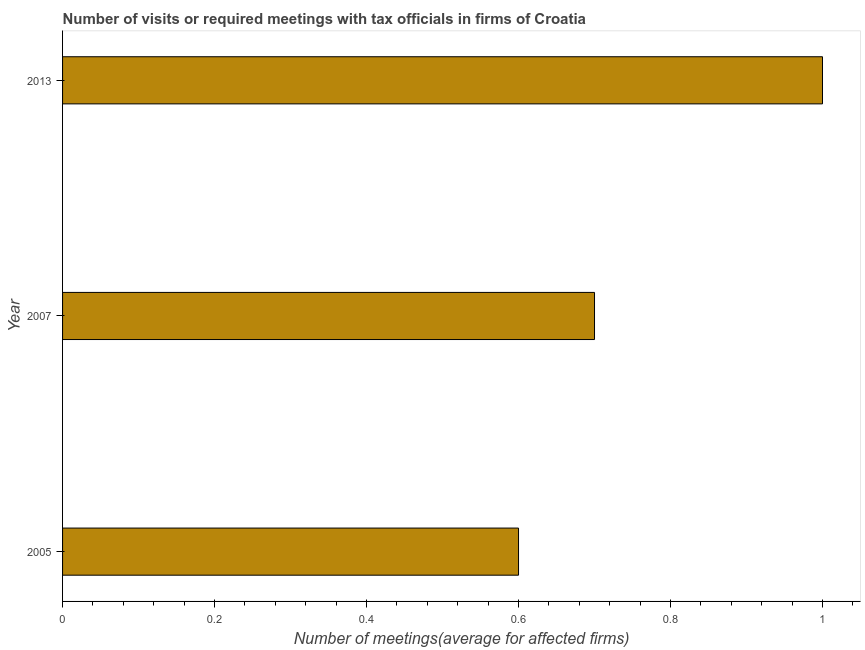What is the title of the graph?
Your answer should be compact. Number of visits or required meetings with tax officials in firms of Croatia. What is the label or title of the X-axis?
Your response must be concise. Number of meetings(average for affected firms). What is the number of required meetings with tax officials in 2005?
Your answer should be very brief. 0.6. What is the sum of the number of required meetings with tax officials?
Your response must be concise. 2.3. What is the difference between the number of required meetings with tax officials in 2007 and 2013?
Ensure brevity in your answer.  -0.3. What is the average number of required meetings with tax officials per year?
Offer a terse response. 0.77. What is the median number of required meetings with tax officials?
Your answer should be very brief. 0.7. In how many years, is the number of required meetings with tax officials greater than 0.24 ?
Give a very brief answer. 3. What is the ratio of the number of required meetings with tax officials in 2005 to that in 2007?
Provide a short and direct response. 0.86. What is the difference between the highest and the second highest number of required meetings with tax officials?
Keep it short and to the point. 0.3. What is the difference between the highest and the lowest number of required meetings with tax officials?
Ensure brevity in your answer.  0.4. In how many years, is the number of required meetings with tax officials greater than the average number of required meetings with tax officials taken over all years?
Keep it short and to the point. 1. How many bars are there?
Keep it short and to the point. 3. How many years are there in the graph?
Offer a terse response. 3. Are the values on the major ticks of X-axis written in scientific E-notation?
Offer a very short reply. No. What is the Number of meetings(average for affected firms) of 2005?
Offer a very short reply. 0.6. What is the difference between the Number of meetings(average for affected firms) in 2005 and 2013?
Your response must be concise. -0.4. What is the ratio of the Number of meetings(average for affected firms) in 2005 to that in 2007?
Offer a very short reply. 0.86. What is the ratio of the Number of meetings(average for affected firms) in 2005 to that in 2013?
Your answer should be compact. 0.6. 